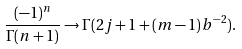Convert formula to latex. <formula><loc_0><loc_0><loc_500><loc_500>\frac { ( - 1 ) ^ { n } } { \Gamma ( n + 1 ) } \rightarrow \Gamma ( 2 j + 1 + ( m - 1 ) b ^ { - 2 } ) .</formula> 